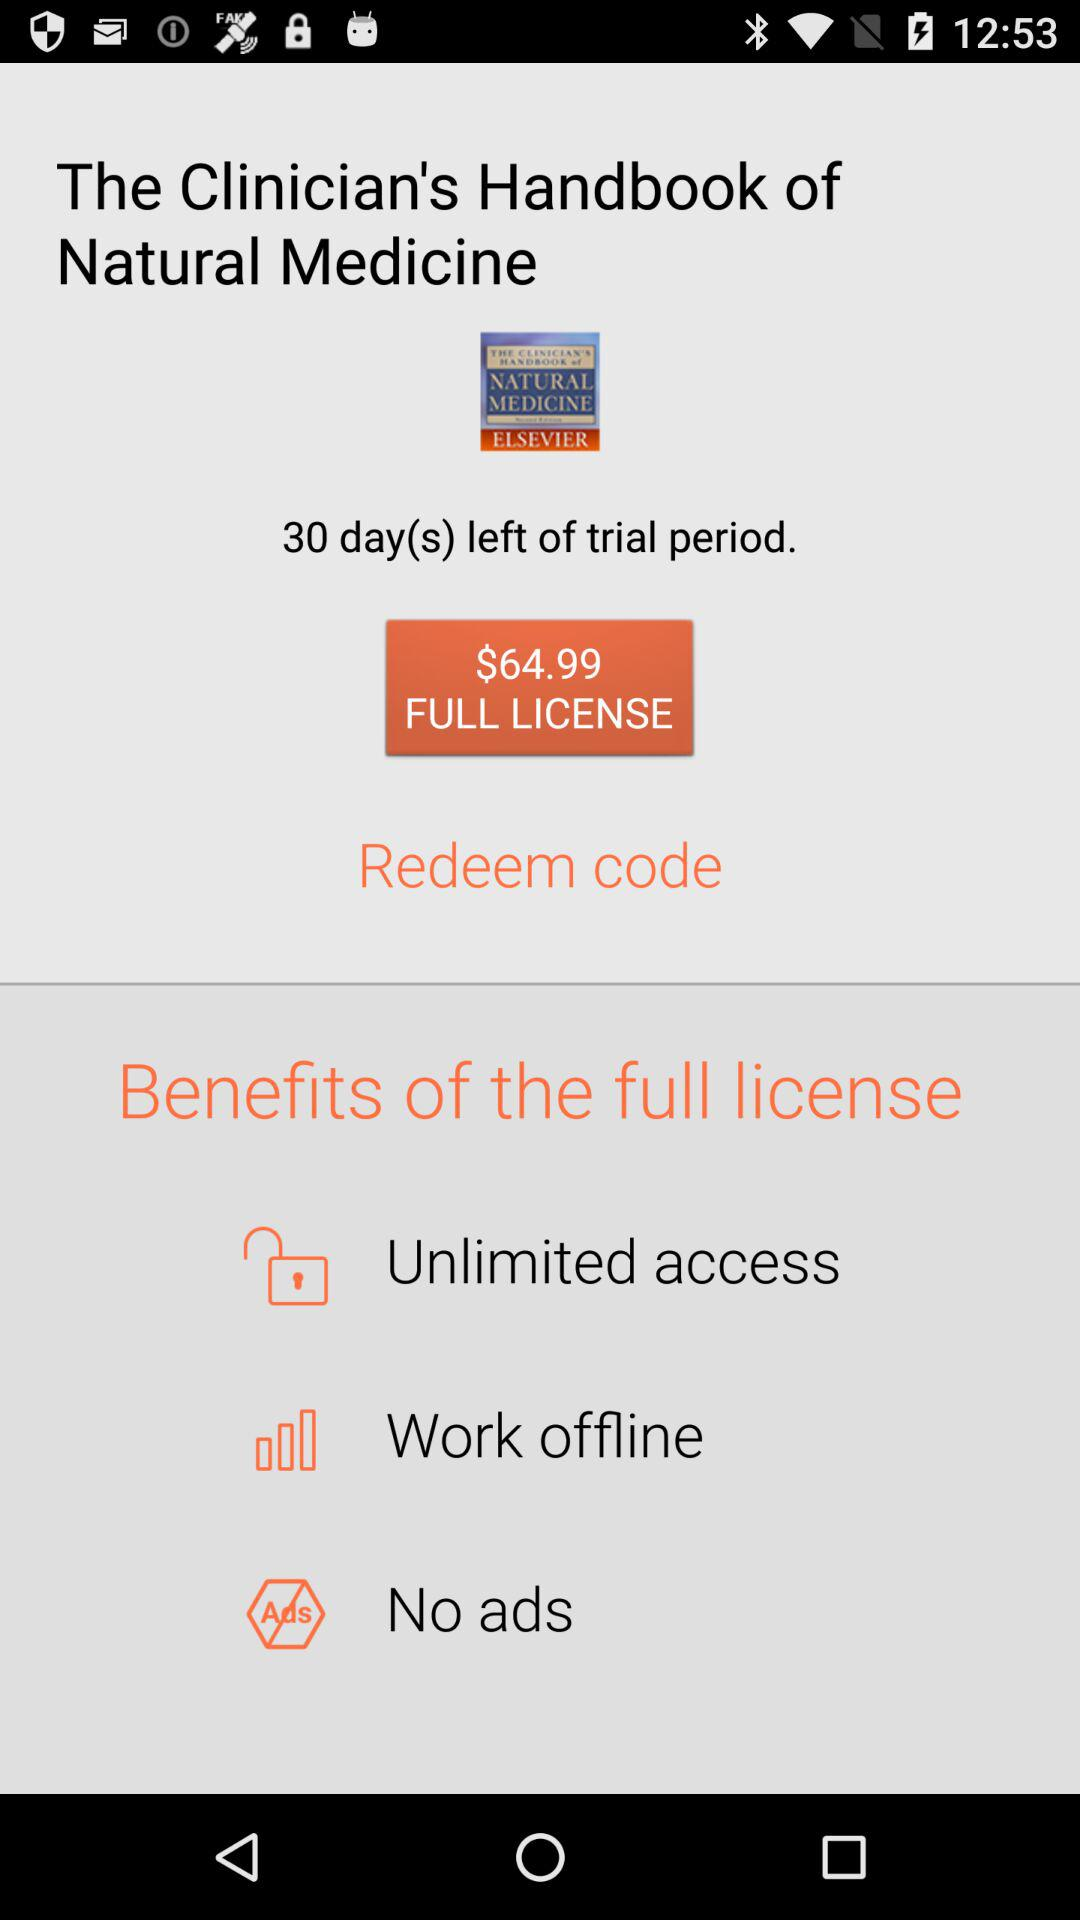What are the benefits of the full license? The benefits are "Unlimited access", "Work offline" and "No ads". 